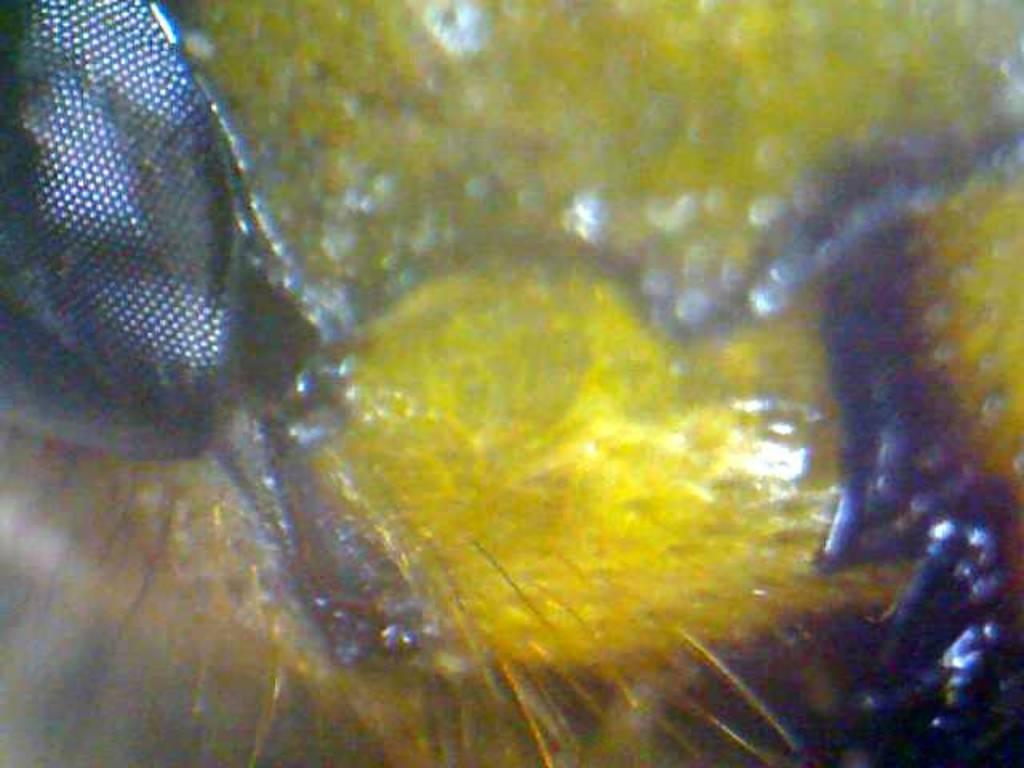What type of living organisms can be seen in the image? Insects can be seen in the image. What type of manager is overseeing the balloon in the image? There is no manager or balloon present in the image; it only features insects. 